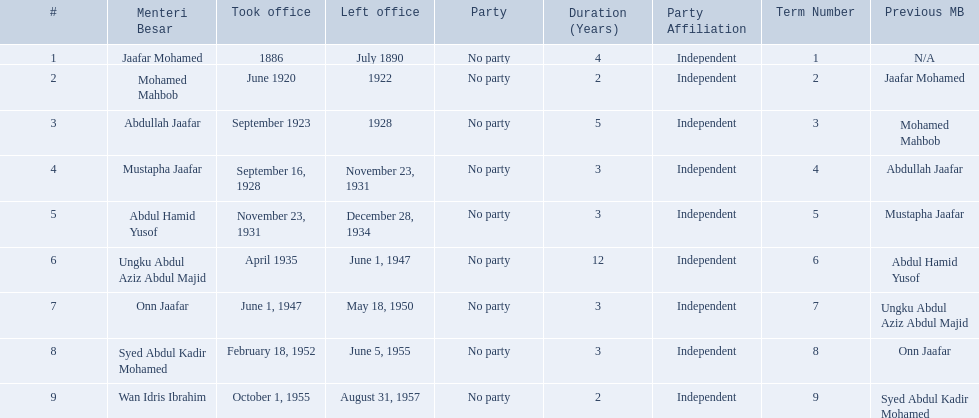Who were the menteri besar of johor? Jaafar Mohamed, Mohamed Mahbob, Abdullah Jaafar, Mustapha Jaafar, Abdul Hamid Yusof, Ungku Abdul Aziz Abdul Majid, Onn Jaafar, Syed Abdul Kadir Mohamed, Wan Idris Ibrahim. Who served the longest? Ungku Abdul Aziz Abdul Majid. 